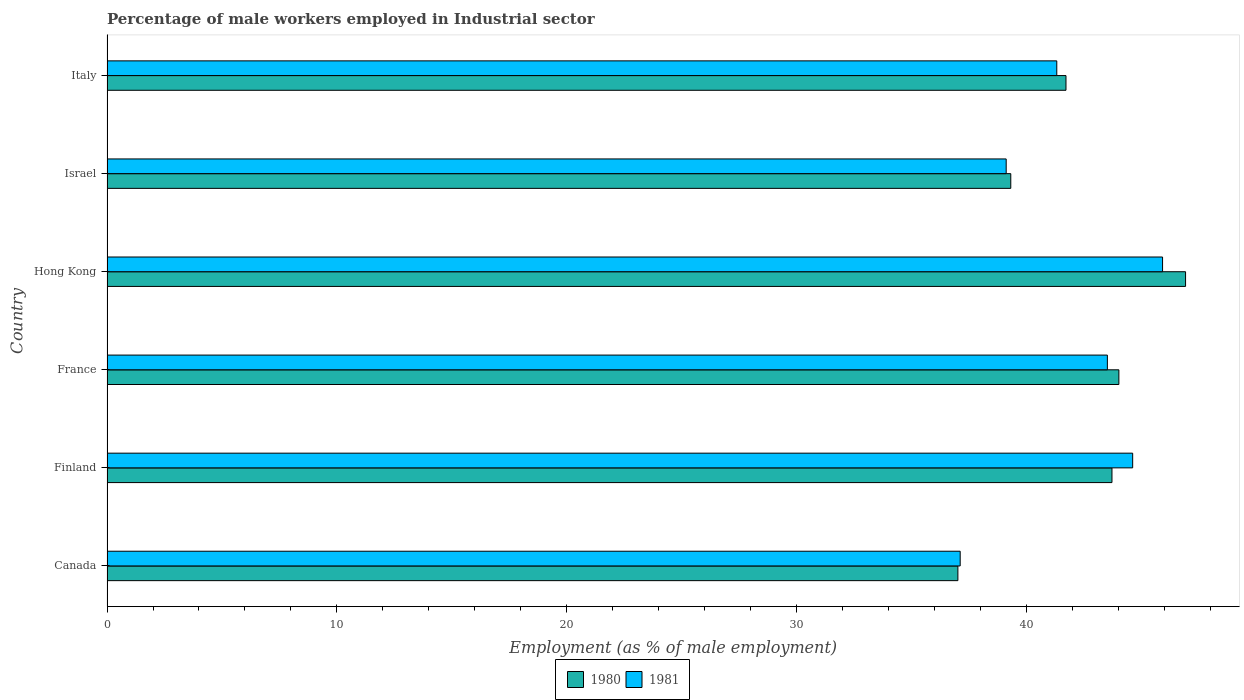How many different coloured bars are there?
Ensure brevity in your answer.  2. How many groups of bars are there?
Offer a very short reply. 6. In how many cases, is the number of bars for a given country not equal to the number of legend labels?
Keep it short and to the point. 0. What is the percentage of male workers employed in Industrial sector in 1981 in France?
Keep it short and to the point. 43.5. Across all countries, what is the maximum percentage of male workers employed in Industrial sector in 1981?
Keep it short and to the point. 45.9. Across all countries, what is the minimum percentage of male workers employed in Industrial sector in 1980?
Make the answer very short. 37. In which country was the percentage of male workers employed in Industrial sector in 1981 maximum?
Give a very brief answer. Hong Kong. In which country was the percentage of male workers employed in Industrial sector in 1981 minimum?
Make the answer very short. Canada. What is the total percentage of male workers employed in Industrial sector in 1981 in the graph?
Keep it short and to the point. 251.5. What is the difference between the percentage of male workers employed in Industrial sector in 1980 in Canada and that in Israel?
Keep it short and to the point. -2.3. What is the difference between the percentage of male workers employed in Industrial sector in 1980 in Hong Kong and the percentage of male workers employed in Industrial sector in 1981 in Italy?
Offer a very short reply. 5.6. What is the average percentage of male workers employed in Industrial sector in 1981 per country?
Your answer should be compact. 41.92. What is the difference between the percentage of male workers employed in Industrial sector in 1980 and percentage of male workers employed in Industrial sector in 1981 in Italy?
Your answer should be very brief. 0.4. In how many countries, is the percentage of male workers employed in Industrial sector in 1980 greater than 42 %?
Offer a very short reply. 3. What is the ratio of the percentage of male workers employed in Industrial sector in 1981 in Israel to that in Italy?
Keep it short and to the point. 0.95. Is the percentage of male workers employed in Industrial sector in 1980 in Canada less than that in Finland?
Provide a succinct answer. Yes. Is the difference between the percentage of male workers employed in Industrial sector in 1980 in Canada and Hong Kong greater than the difference between the percentage of male workers employed in Industrial sector in 1981 in Canada and Hong Kong?
Provide a short and direct response. No. What is the difference between the highest and the second highest percentage of male workers employed in Industrial sector in 1981?
Provide a succinct answer. 1.3. What is the difference between the highest and the lowest percentage of male workers employed in Industrial sector in 1980?
Provide a succinct answer. 9.9. Are the values on the major ticks of X-axis written in scientific E-notation?
Provide a succinct answer. No. How many legend labels are there?
Offer a very short reply. 2. How are the legend labels stacked?
Offer a terse response. Horizontal. What is the title of the graph?
Ensure brevity in your answer.  Percentage of male workers employed in Industrial sector. Does "2000" appear as one of the legend labels in the graph?
Offer a very short reply. No. What is the label or title of the X-axis?
Offer a terse response. Employment (as % of male employment). What is the Employment (as % of male employment) of 1981 in Canada?
Your answer should be compact. 37.1. What is the Employment (as % of male employment) in 1980 in Finland?
Provide a succinct answer. 43.7. What is the Employment (as % of male employment) in 1981 in Finland?
Provide a short and direct response. 44.6. What is the Employment (as % of male employment) of 1981 in France?
Provide a short and direct response. 43.5. What is the Employment (as % of male employment) of 1980 in Hong Kong?
Offer a terse response. 46.9. What is the Employment (as % of male employment) in 1981 in Hong Kong?
Make the answer very short. 45.9. What is the Employment (as % of male employment) in 1980 in Israel?
Offer a very short reply. 39.3. What is the Employment (as % of male employment) of 1981 in Israel?
Your response must be concise. 39.1. What is the Employment (as % of male employment) of 1980 in Italy?
Your response must be concise. 41.7. What is the Employment (as % of male employment) in 1981 in Italy?
Provide a short and direct response. 41.3. Across all countries, what is the maximum Employment (as % of male employment) in 1980?
Offer a terse response. 46.9. Across all countries, what is the maximum Employment (as % of male employment) of 1981?
Give a very brief answer. 45.9. Across all countries, what is the minimum Employment (as % of male employment) of 1981?
Offer a terse response. 37.1. What is the total Employment (as % of male employment) in 1980 in the graph?
Your answer should be compact. 252.6. What is the total Employment (as % of male employment) of 1981 in the graph?
Offer a terse response. 251.5. What is the difference between the Employment (as % of male employment) in 1980 in Canada and that in Finland?
Your answer should be compact. -6.7. What is the difference between the Employment (as % of male employment) of 1981 in Canada and that in Finland?
Provide a succinct answer. -7.5. What is the difference between the Employment (as % of male employment) of 1980 in Canada and that in France?
Provide a short and direct response. -7. What is the difference between the Employment (as % of male employment) of 1980 in Canada and that in Hong Kong?
Give a very brief answer. -9.9. What is the difference between the Employment (as % of male employment) in 1981 in Canada and that in Israel?
Your response must be concise. -2. What is the difference between the Employment (as % of male employment) in 1980 in Canada and that in Italy?
Ensure brevity in your answer.  -4.7. What is the difference between the Employment (as % of male employment) of 1981 in Canada and that in Italy?
Give a very brief answer. -4.2. What is the difference between the Employment (as % of male employment) in 1981 in Finland and that in France?
Provide a succinct answer. 1.1. What is the difference between the Employment (as % of male employment) of 1980 in Finland and that in Hong Kong?
Your response must be concise. -3.2. What is the difference between the Employment (as % of male employment) of 1980 in Finland and that in Italy?
Offer a terse response. 2. What is the difference between the Employment (as % of male employment) of 1981 in Finland and that in Italy?
Offer a very short reply. 3.3. What is the difference between the Employment (as % of male employment) in 1980 in France and that in Hong Kong?
Provide a succinct answer. -2.9. What is the difference between the Employment (as % of male employment) in 1981 in France and that in Israel?
Your answer should be very brief. 4.4. What is the difference between the Employment (as % of male employment) in 1980 in France and that in Italy?
Your response must be concise. 2.3. What is the difference between the Employment (as % of male employment) in 1981 in France and that in Italy?
Offer a very short reply. 2.2. What is the difference between the Employment (as % of male employment) of 1980 in Hong Kong and that in Italy?
Ensure brevity in your answer.  5.2. What is the difference between the Employment (as % of male employment) in 1980 in Israel and that in Italy?
Ensure brevity in your answer.  -2.4. What is the difference between the Employment (as % of male employment) of 1980 in Canada and the Employment (as % of male employment) of 1981 in France?
Offer a terse response. -6.5. What is the difference between the Employment (as % of male employment) of 1980 in Canada and the Employment (as % of male employment) of 1981 in Hong Kong?
Offer a terse response. -8.9. What is the difference between the Employment (as % of male employment) in 1980 in Finland and the Employment (as % of male employment) in 1981 in Hong Kong?
Offer a terse response. -2.2. What is the difference between the Employment (as % of male employment) of 1980 in Finland and the Employment (as % of male employment) of 1981 in Israel?
Offer a terse response. 4.6. What is the difference between the Employment (as % of male employment) of 1980 in Finland and the Employment (as % of male employment) of 1981 in Italy?
Your answer should be compact. 2.4. What is the difference between the Employment (as % of male employment) of 1980 in France and the Employment (as % of male employment) of 1981 in Hong Kong?
Your response must be concise. -1.9. What is the difference between the Employment (as % of male employment) of 1980 in France and the Employment (as % of male employment) of 1981 in Israel?
Keep it short and to the point. 4.9. What is the difference between the Employment (as % of male employment) of 1980 in France and the Employment (as % of male employment) of 1981 in Italy?
Make the answer very short. 2.7. What is the difference between the Employment (as % of male employment) of 1980 in Hong Kong and the Employment (as % of male employment) of 1981 in Italy?
Your answer should be compact. 5.6. What is the difference between the Employment (as % of male employment) in 1980 in Israel and the Employment (as % of male employment) in 1981 in Italy?
Offer a terse response. -2. What is the average Employment (as % of male employment) of 1980 per country?
Ensure brevity in your answer.  42.1. What is the average Employment (as % of male employment) of 1981 per country?
Offer a very short reply. 41.92. What is the difference between the Employment (as % of male employment) in 1980 and Employment (as % of male employment) in 1981 in Hong Kong?
Your response must be concise. 1. What is the difference between the Employment (as % of male employment) in 1980 and Employment (as % of male employment) in 1981 in Israel?
Keep it short and to the point. 0.2. What is the ratio of the Employment (as % of male employment) in 1980 in Canada to that in Finland?
Give a very brief answer. 0.85. What is the ratio of the Employment (as % of male employment) in 1981 in Canada to that in Finland?
Ensure brevity in your answer.  0.83. What is the ratio of the Employment (as % of male employment) in 1980 in Canada to that in France?
Offer a terse response. 0.84. What is the ratio of the Employment (as % of male employment) in 1981 in Canada to that in France?
Ensure brevity in your answer.  0.85. What is the ratio of the Employment (as % of male employment) of 1980 in Canada to that in Hong Kong?
Your answer should be very brief. 0.79. What is the ratio of the Employment (as % of male employment) in 1981 in Canada to that in Hong Kong?
Your answer should be compact. 0.81. What is the ratio of the Employment (as % of male employment) of 1980 in Canada to that in Israel?
Give a very brief answer. 0.94. What is the ratio of the Employment (as % of male employment) of 1981 in Canada to that in Israel?
Offer a very short reply. 0.95. What is the ratio of the Employment (as % of male employment) in 1980 in Canada to that in Italy?
Offer a very short reply. 0.89. What is the ratio of the Employment (as % of male employment) in 1981 in Canada to that in Italy?
Make the answer very short. 0.9. What is the ratio of the Employment (as % of male employment) of 1980 in Finland to that in France?
Your answer should be very brief. 0.99. What is the ratio of the Employment (as % of male employment) of 1981 in Finland to that in France?
Your answer should be very brief. 1.03. What is the ratio of the Employment (as % of male employment) in 1980 in Finland to that in Hong Kong?
Your answer should be very brief. 0.93. What is the ratio of the Employment (as % of male employment) of 1981 in Finland to that in Hong Kong?
Keep it short and to the point. 0.97. What is the ratio of the Employment (as % of male employment) of 1980 in Finland to that in Israel?
Make the answer very short. 1.11. What is the ratio of the Employment (as % of male employment) of 1981 in Finland to that in Israel?
Offer a terse response. 1.14. What is the ratio of the Employment (as % of male employment) of 1980 in Finland to that in Italy?
Provide a succinct answer. 1.05. What is the ratio of the Employment (as % of male employment) in 1981 in Finland to that in Italy?
Your response must be concise. 1.08. What is the ratio of the Employment (as % of male employment) in 1980 in France to that in Hong Kong?
Offer a very short reply. 0.94. What is the ratio of the Employment (as % of male employment) in 1981 in France to that in Hong Kong?
Provide a short and direct response. 0.95. What is the ratio of the Employment (as % of male employment) in 1980 in France to that in Israel?
Ensure brevity in your answer.  1.12. What is the ratio of the Employment (as % of male employment) in 1981 in France to that in Israel?
Make the answer very short. 1.11. What is the ratio of the Employment (as % of male employment) of 1980 in France to that in Italy?
Ensure brevity in your answer.  1.06. What is the ratio of the Employment (as % of male employment) of 1981 in France to that in Italy?
Your answer should be compact. 1.05. What is the ratio of the Employment (as % of male employment) of 1980 in Hong Kong to that in Israel?
Offer a terse response. 1.19. What is the ratio of the Employment (as % of male employment) in 1981 in Hong Kong to that in Israel?
Your answer should be very brief. 1.17. What is the ratio of the Employment (as % of male employment) of 1980 in Hong Kong to that in Italy?
Keep it short and to the point. 1.12. What is the ratio of the Employment (as % of male employment) of 1981 in Hong Kong to that in Italy?
Your answer should be very brief. 1.11. What is the ratio of the Employment (as % of male employment) in 1980 in Israel to that in Italy?
Offer a terse response. 0.94. What is the ratio of the Employment (as % of male employment) in 1981 in Israel to that in Italy?
Give a very brief answer. 0.95. What is the difference between the highest and the second highest Employment (as % of male employment) in 1980?
Your answer should be very brief. 2.9. What is the difference between the highest and the second highest Employment (as % of male employment) in 1981?
Offer a very short reply. 1.3. What is the difference between the highest and the lowest Employment (as % of male employment) of 1980?
Offer a very short reply. 9.9. What is the difference between the highest and the lowest Employment (as % of male employment) of 1981?
Your response must be concise. 8.8. 